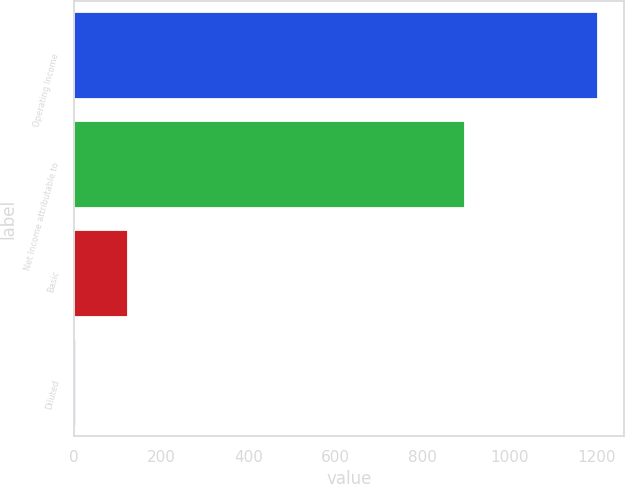<chart> <loc_0><loc_0><loc_500><loc_500><bar_chart><fcel>Operating Income<fcel>Net Income attributable to<fcel>Basic<fcel>Diluted<nl><fcel>1202.6<fcel>896.8<fcel>123.72<fcel>3.85<nl></chart> 